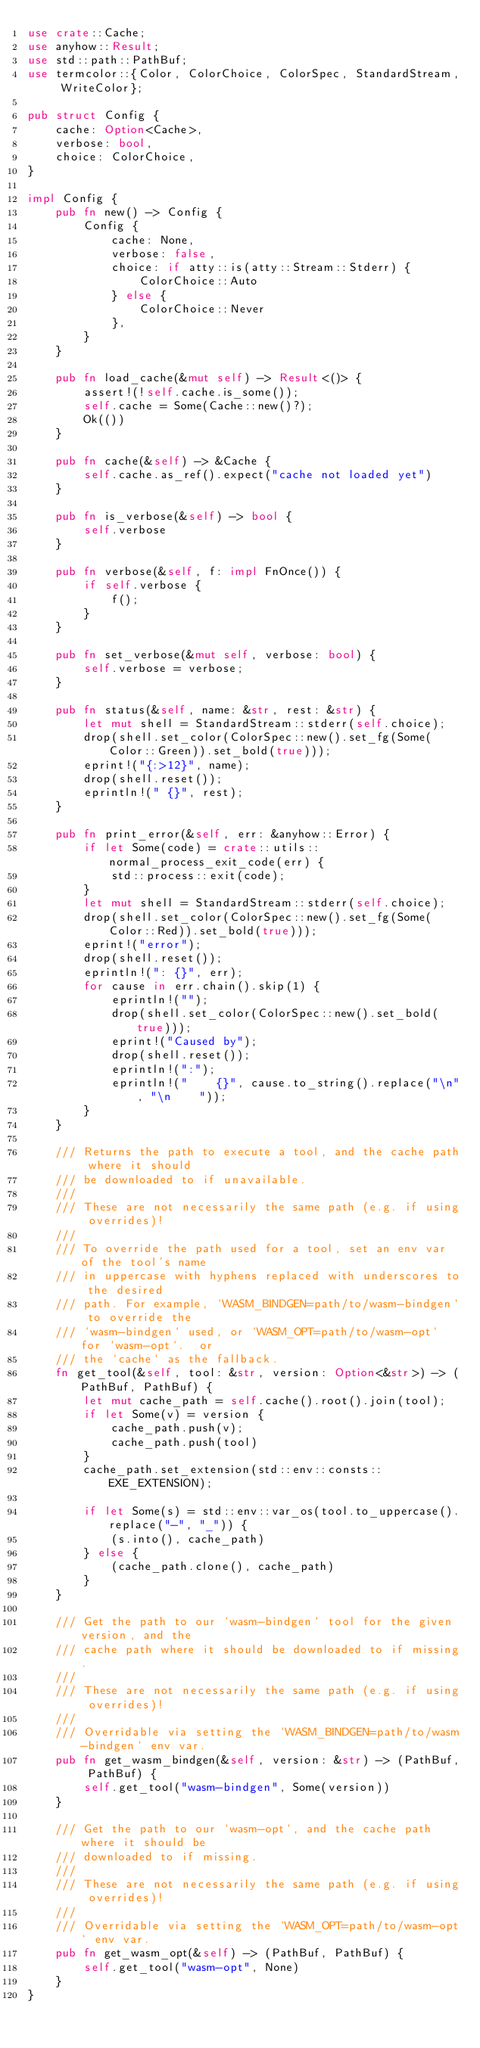<code> <loc_0><loc_0><loc_500><loc_500><_Rust_>use crate::Cache;
use anyhow::Result;
use std::path::PathBuf;
use termcolor::{Color, ColorChoice, ColorSpec, StandardStream, WriteColor};

pub struct Config {
    cache: Option<Cache>,
    verbose: bool,
    choice: ColorChoice,
}

impl Config {
    pub fn new() -> Config {
        Config {
            cache: None,
            verbose: false,
            choice: if atty::is(atty::Stream::Stderr) {
                ColorChoice::Auto
            } else {
                ColorChoice::Never
            },
        }
    }

    pub fn load_cache(&mut self) -> Result<()> {
        assert!(!self.cache.is_some());
        self.cache = Some(Cache::new()?);
        Ok(())
    }

    pub fn cache(&self) -> &Cache {
        self.cache.as_ref().expect("cache not loaded yet")
    }

    pub fn is_verbose(&self) -> bool {
        self.verbose
    }

    pub fn verbose(&self, f: impl FnOnce()) {
        if self.verbose {
            f();
        }
    }

    pub fn set_verbose(&mut self, verbose: bool) {
        self.verbose = verbose;
    }

    pub fn status(&self, name: &str, rest: &str) {
        let mut shell = StandardStream::stderr(self.choice);
        drop(shell.set_color(ColorSpec::new().set_fg(Some(Color::Green)).set_bold(true)));
        eprint!("{:>12}", name);
        drop(shell.reset());
        eprintln!(" {}", rest);
    }

    pub fn print_error(&self, err: &anyhow::Error) {
        if let Some(code) = crate::utils::normal_process_exit_code(err) {
            std::process::exit(code);
        }
        let mut shell = StandardStream::stderr(self.choice);
        drop(shell.set_color(ColorSpec::new().set_fg(Some(Color::Red)).set_bold(true)));
        eprint!("error");
        drop(shell.reset());
        eprintln!(": {}", err);
        for cause in err.chain().skip(1) {
            eprintln!("");
            drop(shell.set_color(ColorSpec::new().set_bold(true)));
            eprint!("Caused by");
            drop(shell.reset());
            eprintln!(":");
            eprintln!("    {}", cause.to_string().replace("\n", "\n    "));
        }
    }

    /// Returns the path to execute a tool, and the cache path where it should
    /// be downloaded to if unavailable.
    ///
    /// These are not necessarily the same path (e.g. if using overrides)!
    ///
    /// To override the path used for a tool, set an env var of the tool's name
    /// in uppercase with hyphens replaced with underscores to the desired
    /// path. For example, `WASM_BINDGEN=path/to/wasm-bindgen` to override the
    /// `wasm-bindgen` used, or `WASM_OPT=path/to/wasm-opt` for `wasm-opt`.  or
    /// the `cache` as the fallback.
    fn get_tool(&self, tool: &str, version: Option<&str>) -> (PathBuf, PathBuf) {
        let mut cache_path = self.cache().root().join(tool);
        if let Some(v) = version {
            cache_path.push(v);
            cache_path.push(tool)
        }
        cache_path.set_extension(std::env::consts::EXE_EXTENSION);

        if let Some(s) = std::env::var_os(tool.to_uppercase().replace("-", "_")) {
            (s.into(), cache_path)
        } else {
            (cache_path.clone(), cache_path)
        }
    }

    /// Get the path to our `wasm-bindgen` tool for the given version, and the
    /// cache path where it should be downloaded to if missing.
    ///
    /// These are not necessarily the same path (e.g. if using overrides)!
    ///
    /// Overridable via setting the `WASM_BINDGEN=path/to/wasm-bindgen` env var.
    pub fn get_wasm_bindgen(&self, version: &str) -> (PathBuf, PathBuf) {
        self.get_tool("wasm-bindgen", Some(version))
    }

    /// Get the path to our `wasm-opt`, and the cache path where it should be
    /// downloaded to if missing.
    ///
    /// These are not necessarily the same path (e.g. if using overrides)!
    ///
    /// Overridable via setting the `WASM_OPT=path/to/wasm-opt` env var.
    pub fn get_wasm_opt(&self) -> (PathBuf, PathBuf) {
        self.get_tool("wasm-opt", None)
    }
}
</code> 